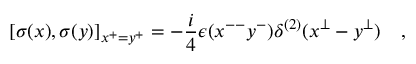<formula> <loc_0><loc_0><loc_500><loc_500>[ \sigma ( x ) , \sigma ( y ) ] _ { x ^ { + } = y ^ { + } } = - \frac { i } { 4 } \epsilon ( x ^ { - - } y ^ { - } ) \delta ^ { ( 2 ) } ( x ^ { \perp } - y ^ { \perp } ) \quad ,</formula> 